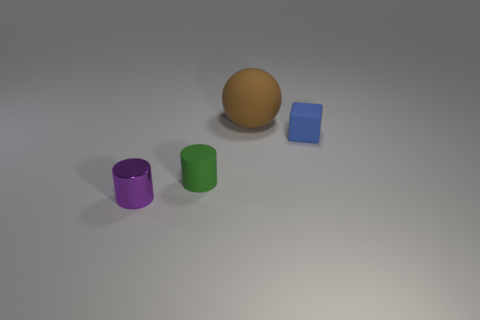What size is the matte thing that is in front of the tiny matte object behind the green rubber object?
Make the answer very short. Small. The thing that is behind the green object and left of the matte block is what color?
Offer a very short reply. Brown. There is a green cylinder that is the same size as the blue rubber cube; what is its material?
Your answer should be compact. Rubber. What number of other things are there of the same material as the large brown ball
Provide a succinct answer. 2. There is a small object that is behind the small cylinder behind the small purple shiny thing; what shape is it?
Keep it short and to the point. Cube. How many other things are the same color as the large ball?
Your answer should be very brief. 0. Does the small thing that is on the right side of the small matte cylinder have the same material as the cylinder that is to the right of the purple shiny cylinder?
Offer a very short reply. Yes. There is a object behind the blue cube; what is its size?
Ensure brevity in your answer.  Large. What material is the small purple object that is the same shape as the small green thing?
Offer a terse response. Metal. Is there anything else that has the same size as the brown ball?
Provide a short and direct response. No. 